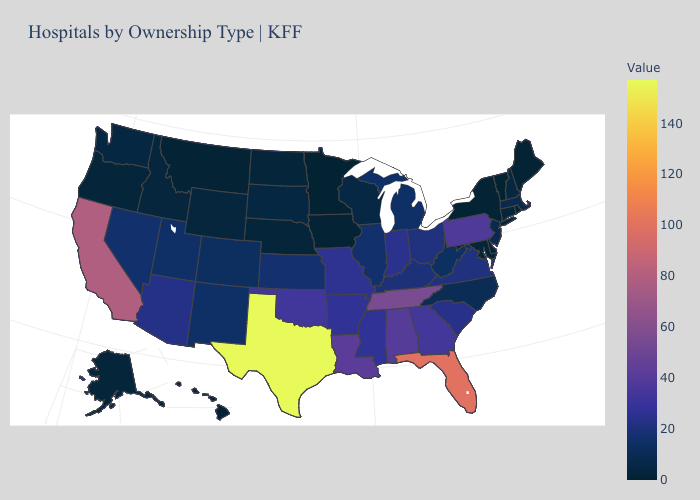Does Wyoming have the highest value in the West?
Write a very short answer. No. Among the states that border Kansas , does Oklahoma have the highest value?
Answer briefly. Yes. Among the states that border Washington , which have the lowest value?
Answer briefly. Oregon. Which states have the lowest value in the West?
Keep it brief. Hawaii. Is the legend a continuous bar?
Concise answer only. Yes. 